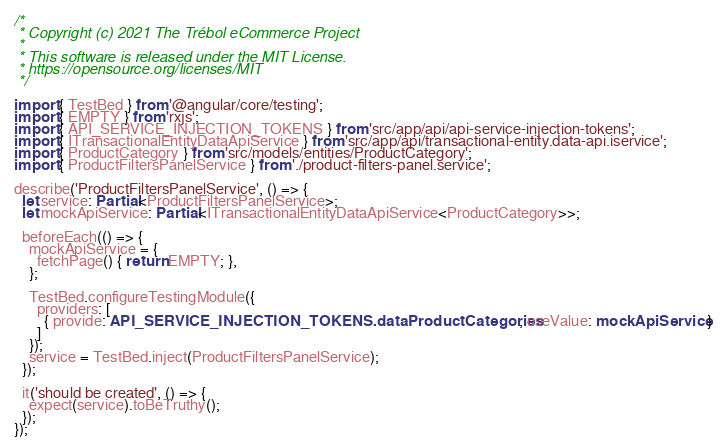Convert code to text. <code><loc_0><loc_0><loc_500><loc_500><_TypeScript_>/*
 * Copyright (c) 2021 The Trébol eCommerce Project
 *
 * This software is released under the MIT License.
 * https://opensource.org/licenses/MIT
 */

import { TestBed } from '@angular/core/testing';
import { EMPTY } from 'rxjs';
import { API_SERVICE_INJECTION_TOKENS } from 'src/app/api/api-service-injection-tokens';
import { ITransactionalEntityDataApiService } from 'src/app/api/transactional-entity.data-api.iservice';
import { ProductCategory } from 'src/models/entities/ProductCategory';
import { ProductFiltersPanelService } from './product-filters-panel.service';

describe('ProductFiltersPanelService', () => {
  let service: Partial<ProductFiltersPanelService>;
  let mockApiService: Partial<ITransactionalEntityDataApiService<ProductCategory>>;

  beforeEach(() => {
    mockApiService = {
      fetchPage() { return EMPTY; },
    };

    TestBed.configureTestingModule({
      providers: [
        { provide: API_SERVICE_INJECTION_TOKENS.dataProductCategories, useValue: mockApiService }
      ]
    });
    service = TestBed.inject(ProductFiltersPanelService);
  });

  it('should be created', () => {
    expect(service).toBeTruthy();
  });
});
</code> 